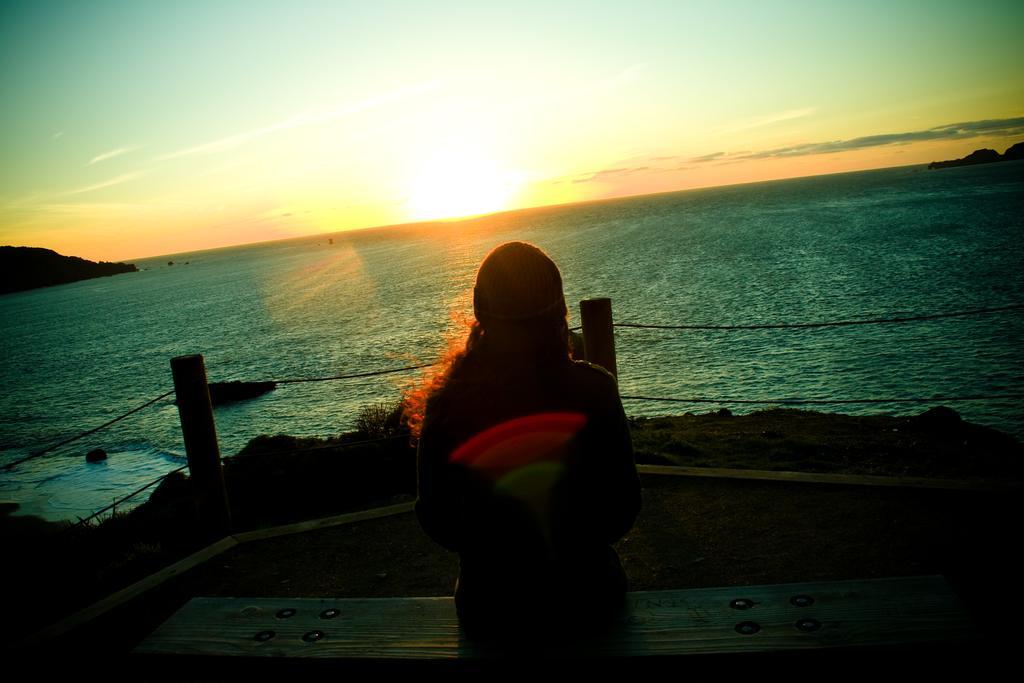In one or two sentences, can you explain what this image depicts? In this image we can see a woman sitting on the bench. In the center of the image we can see ropes and poles. In the background, we can see mountains and sun in the sky. 